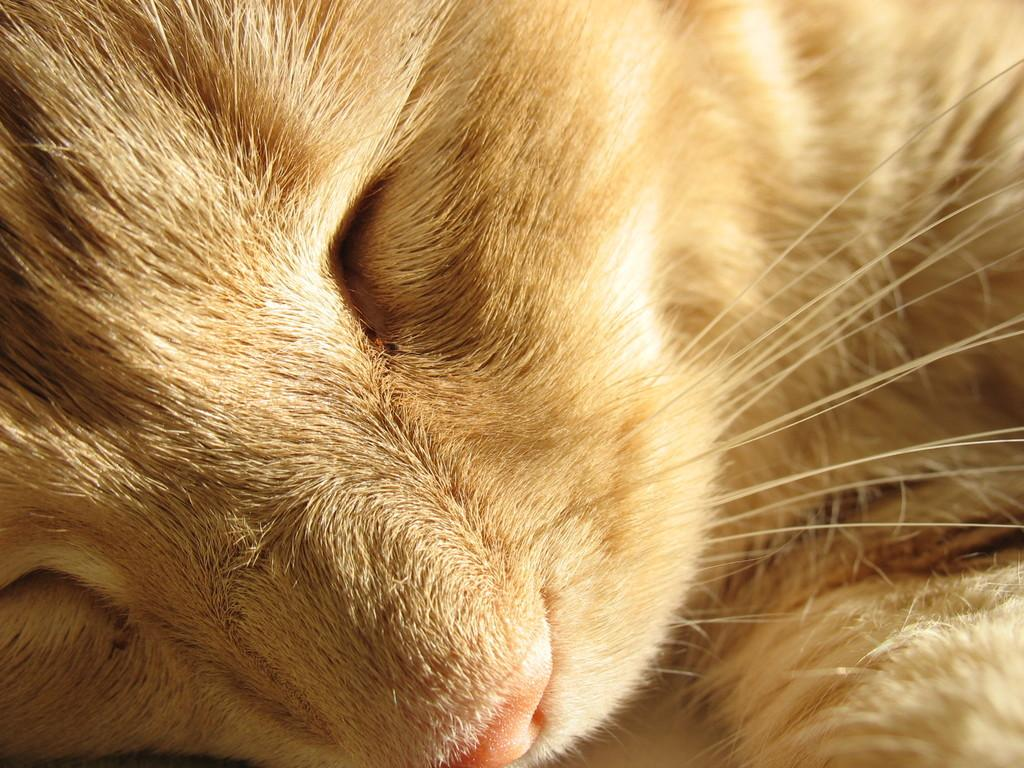What type of animal is in the image? There is a cat in the image. What kind of apparatus is the cat using to communicate in the image? There is no apparatus present in the image, and the cat is not communicating through any device. 